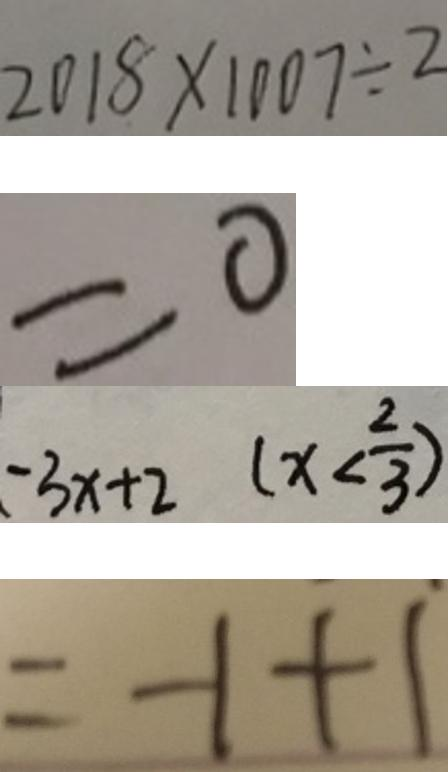<formula> <loc_0><loc_0><loc_500><loc_500>2 0 1 8 \times 1 0 0 7 \div 2 
 = 0 
 - 3 x + 2 ( x < \frac { 2 } { 3 } ) 
 = - 1 + 1</formula> 